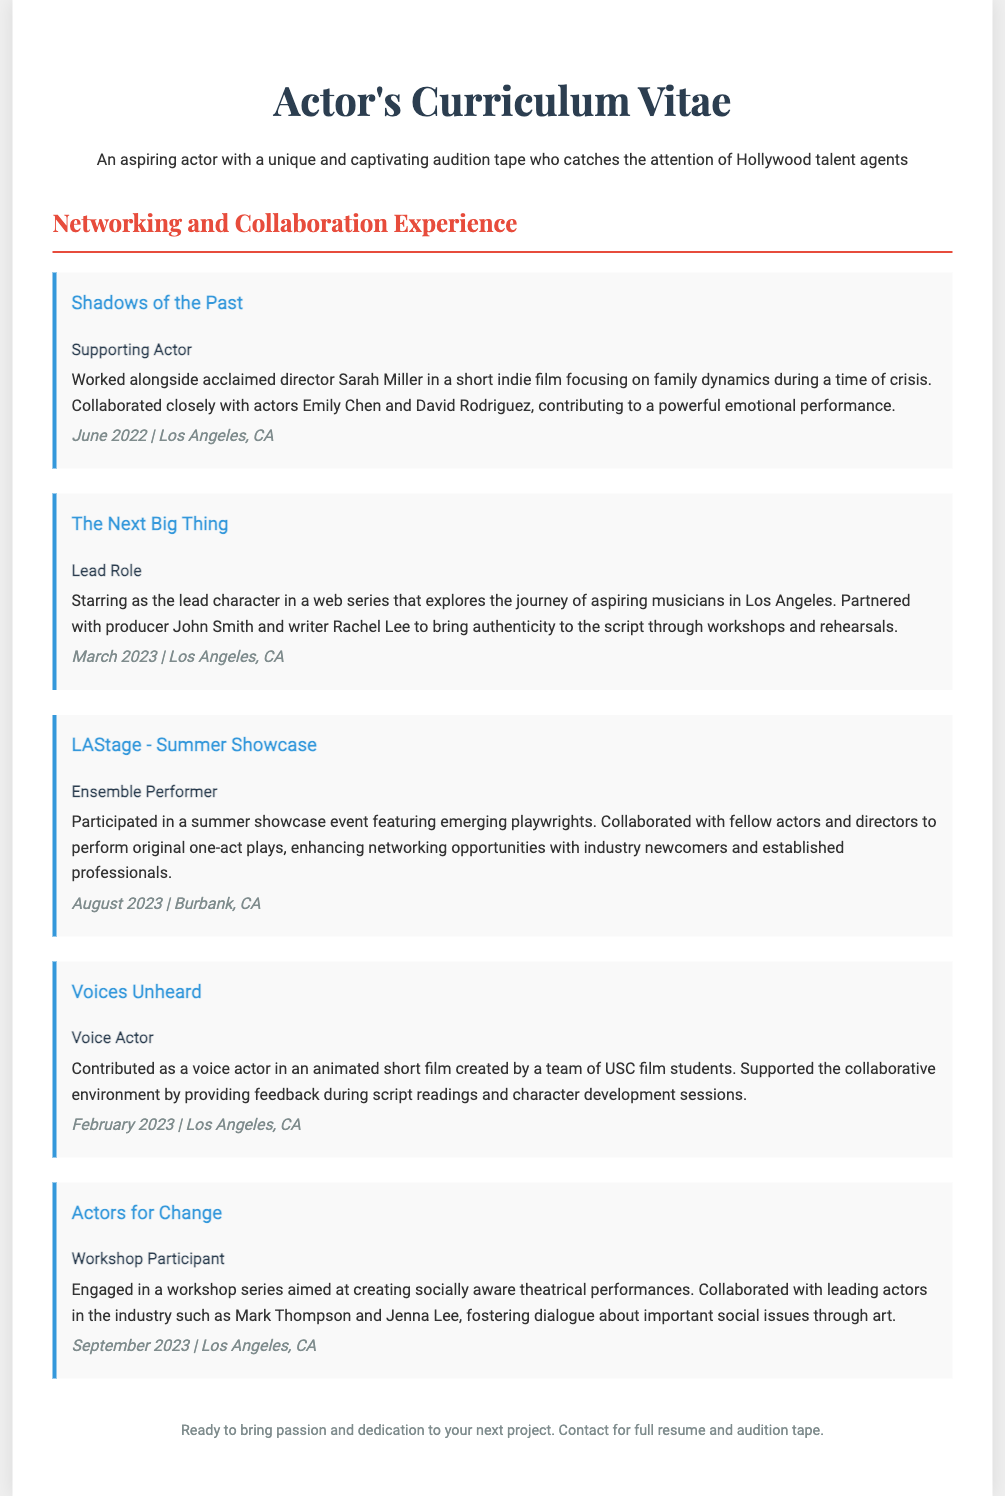What is the title of the first project listed? The title of the first project is stated at the beginning of the section, which is "Shadows of the Past."
Answer: Shadows of the Past Who directed the film "Shadows of the Past"? The name of the director is provided in the description of the project, which is Sarah Miller.
Answer: Sarah Miller In which month and year did the project "Voices Unheard" take place? The date for "Voices Unheard" is given in the document, specifying February 2023.
Answer: February 2023 What role did the actor play in "The Next Big Thing"? The document explicitly states that the actor played the "Lead Role" in this web series.
Answer: Lead Role Which project involved collaboration with USC film students? This project is specifically mentioned in the description of "Voices Unheard," which was created by a team of USC film students.
Answer: Voices Unheard How many months after "Shadows of the Past" did "The Next Big Thing" occur? "Shadows of the Past" was in June 2022 and "The Next Big Thing" in March 2023, which is a span of 9 months.
Answer: 9 months What is the common theme of the web series in which the actor starred? The document states that the web series explores the journey of aspiring musicians.
Answer: Aspiring musicians What type of performance did the actor participate in during the LAStage - Summer Showcase? The document indicates that the actor was an "Ensemble Performer" in the showcase event.
Answer: Ensemble Performer What was the primary purpose of the "Actors for Change" workshop? The primary purpose of this workshop series is to create socially aware theatrical performances.
Answer: Socially aware theatrical performances 